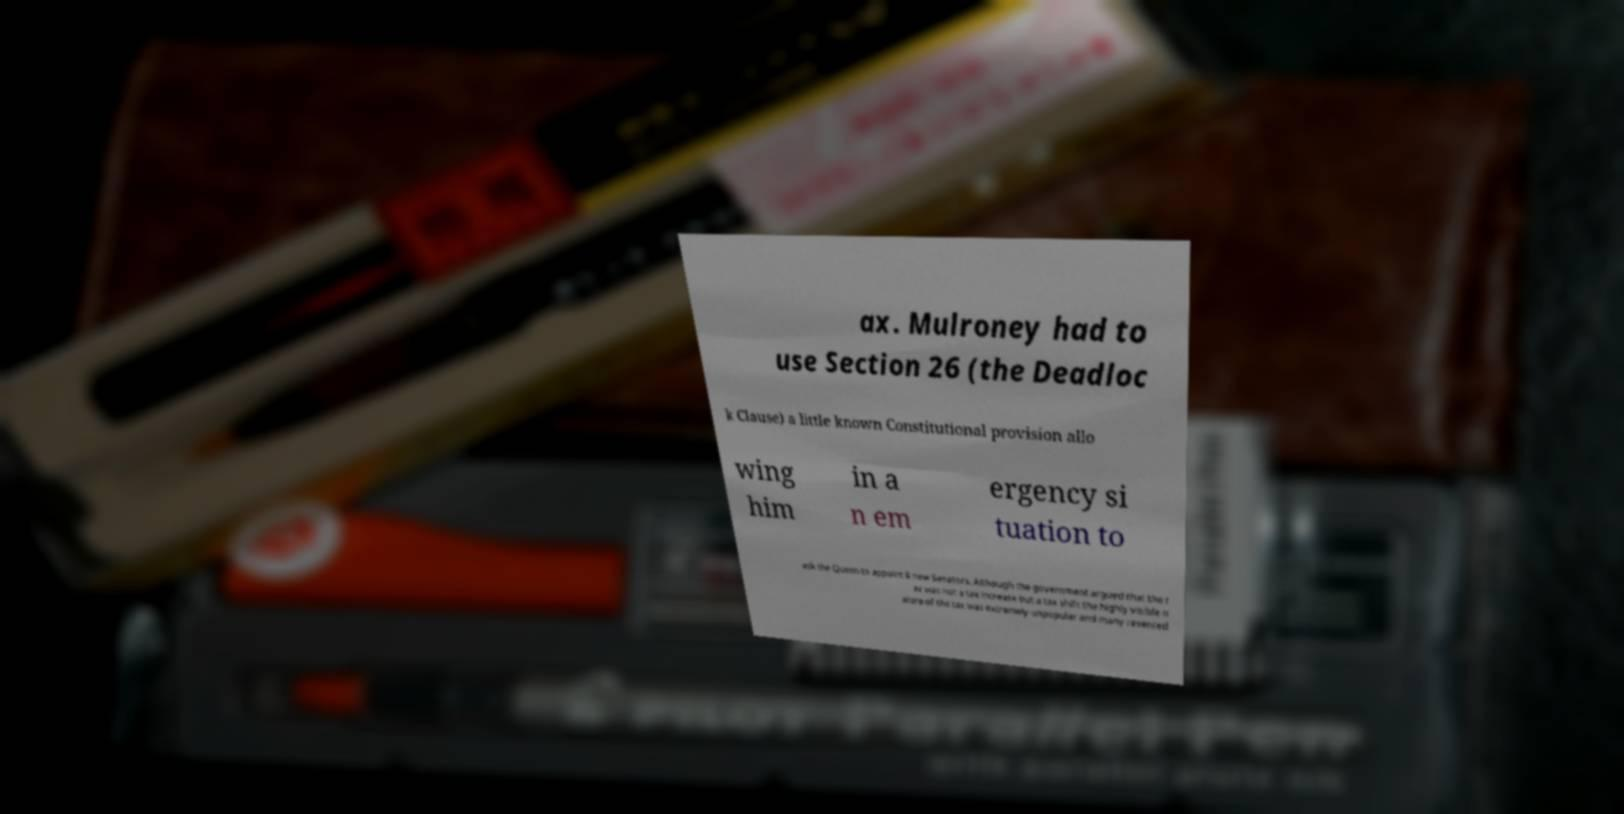Please read and relay the text visible in this image. What does it say? ax. Mulroney had to use Section 26 (the Deadloc k Clause) a little known Constitutional provision allo wing him in a n em ergency si tuation to ask the Queen to appoint 8 new Senators. Although the government argued that the t ax was not a tax increase but a tax shift the highly visible n ature of the tax was extremely unpopular and many resented 